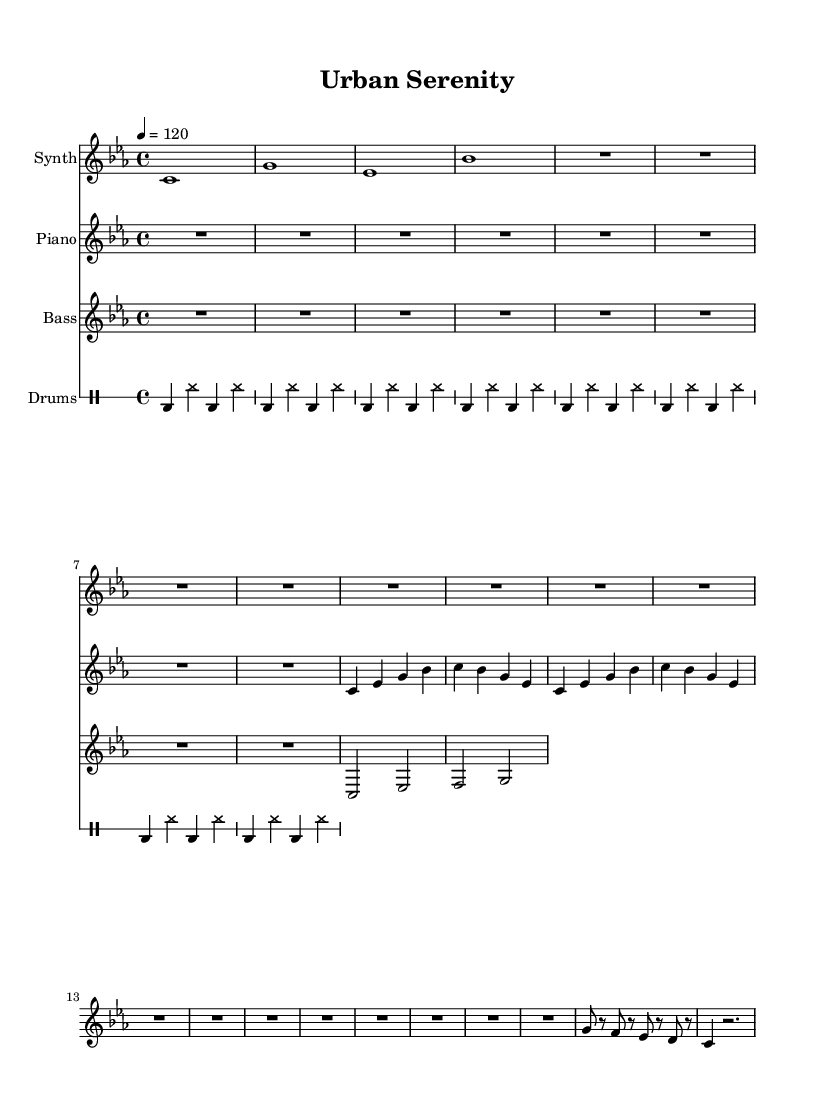What is the key signature of this music? The key signature is C minor, as indicated by the flat notes shown in the music. In this case, there are three flats, which conform to the C minor scale.
Answer: C minor What is the time signature of this music? The time signature is 4/4, as shown at the beginning of the score. This indicates four beats in each measure, which is a standard time signature for many music genres, including deep house.
Answer: 4/4 What is the tempo marking of the piece? The tempo marking indicates that the piece should be played at a speed of 120 beats per minute, as specified in the tempo command seen in the score. This provides a moderate pace that is typical for chill deep house tracks.
Answer: 120 What instruments are featured in this score? The instruments featured are Synth, Piano, Bass, and Drums, as labeled at the beginning of each staff line. This combination is common in house music for creating textured sound layers.
Answer: Synth, Piano, Bass, Drums How many bars are included in the synth break section? The synth break consists of four bars, as we can see by counting the measures within that section of the score. Each measure contains a specific rhythmic pattern that contributes to the overall ambiance.
Answer: 4 What type of rhythm pattern is used in the drum section? The drum section employs a simple kick on the first and third beats and hi-hat on all beats. The repeated patterns create a driving rhythm typical of house music, enhancing the groove.
Answer: Kick and hi-hat pattern 